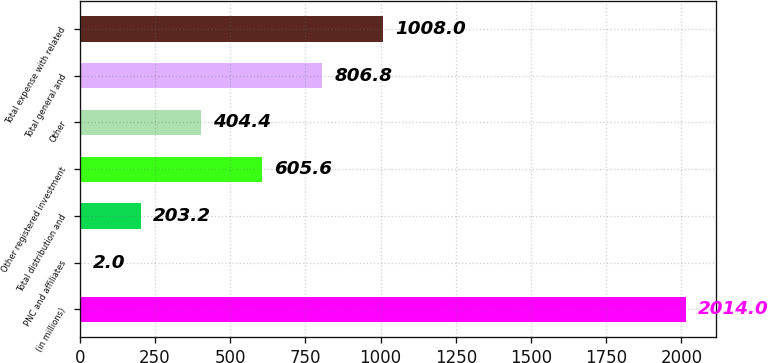Convert chart to OTSL. <chart><loc_0><loc_0><loc_500><loc_500><bar_chart><fcel>(in millions)<fcel>PNC and affiliates<fcel>Total distribution and<fcel>Other registered investment<fcel>Other<fcel>Total general and<fcel>Total expense with related<nl><fcel>2014<fcel>2<fcel>203.2<fcel>605.6<fcel>404.4<fcel>806.8<fcel>1008<nl></chart> 